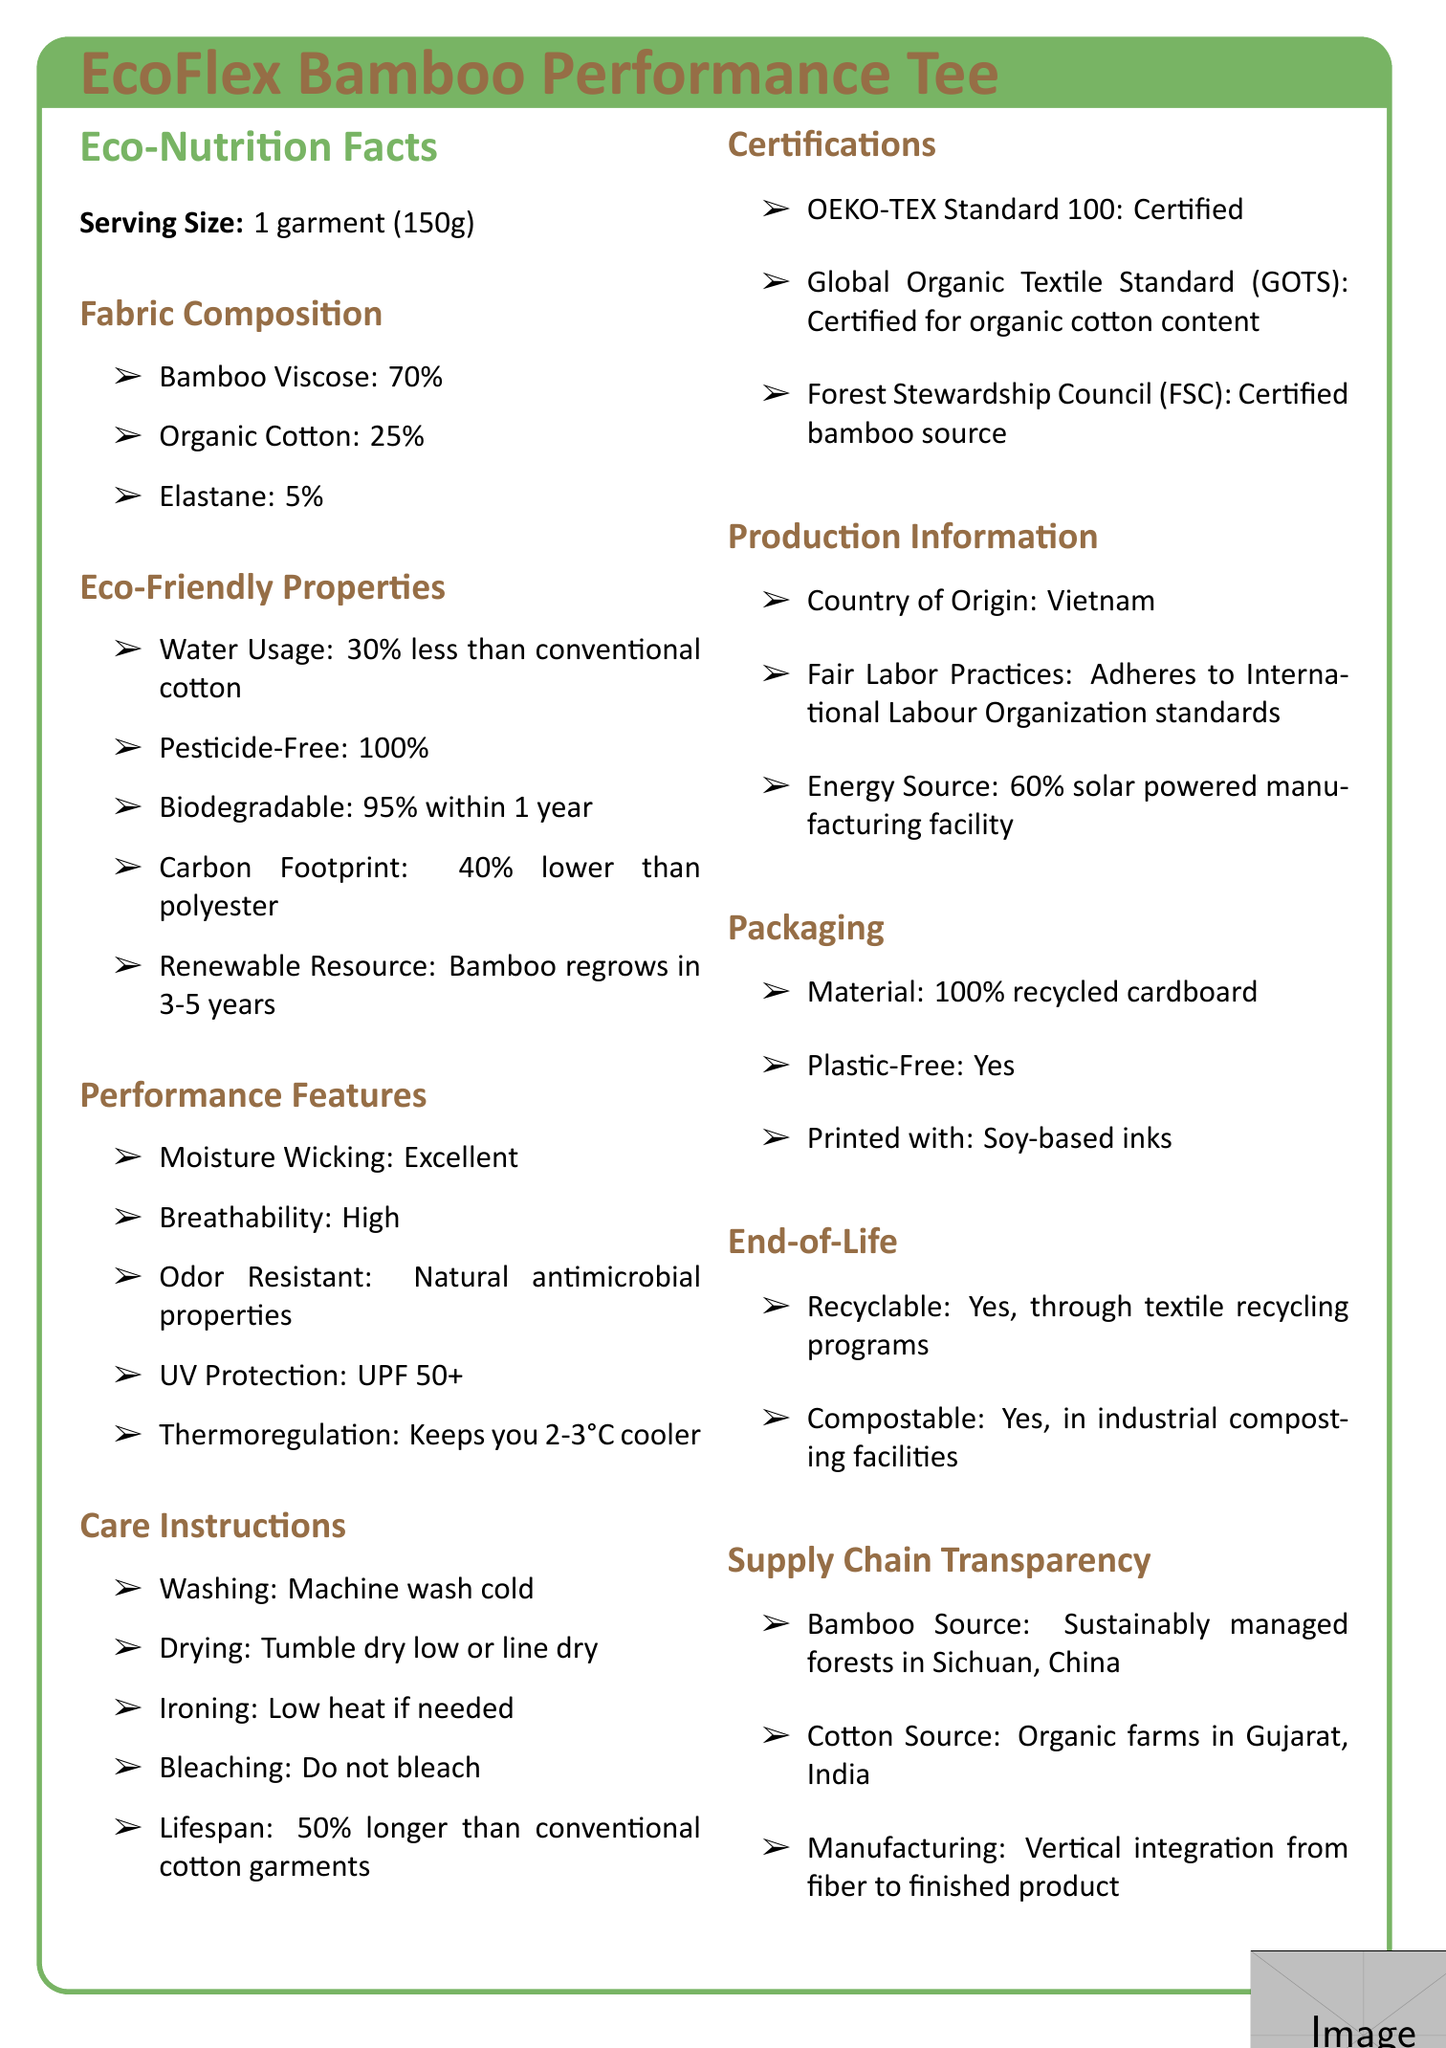what is the serving size of the EcoFlex Bamboo Performance Tee? The serving size is indicated at the beginning of the document under the "Eco-Nutrition Facts" section.
Answer: 1 garment (150g) What percentage of the EcoFlex Bamboo Performance Tee is made of organic cotton? The fabric composition states that the organic cotton content is 25%.
Answer: 25% How much water does the production of this garment save compared to conventional cotton garments? The eco-friendly properties section mentions that water usage is 30% less than conventional cotton.
Answer: 30% less What is one feature of the EcoFlex Bamboo Performance Tee that makes it particularly suitable for outdoor activities? The performance features list includes UV Protection with a UPF of 50+.
Answer: UV Protection: UPF 50+ What is the main energy source for manufacturing the EcoFlex Bamboo Performance Tee? This information is under the production information section.
Answer: 60% solar powered manufacturing facility Which certification ensures the organic cotton content in the EcoFlex Bamboo Performance Tee? A. OEKO-TEX Standard 100 B. Global Organic Textile Standard (GOTS) C. Forest Stewardship Council (FSC) The certifications section specifies that the Global Organic Textile Standard (GOTS) certifies the organic cotton content.
Answer: B. Global Organic Textile Standard (GOTS) Which of the following features is NOT listed under Performance Features? A. Moisture Wicking B. Wind Resistance C. Thermoregulation D. Odor Resistant The document lists Moisture Wicking, Thermoregulation, and Odor Resistant under Performance Features, but not Wind Resistance.
Answer: B. Wind Resistance Is the packaging of the EcoFlex Bamboo Performance Tee plastic-free? The packaging section states that the packaging is plastic-free.
Answer: Yes Summarize the main idea of this document. The EcoFlex Bamboo Performance Tee is highlighted for its sustainable production, excellent performance features, and eco-friendly packaging and certifications.
Answer: The EcoFlex Bamboo Performance Tee is a sustainable and high-performance activewear garment made from eco-friendly materials like bamboo viscose and organic cotton. It has beneficial properties such as reduced water usage, being pesticide-free, biodegradable, and having a lower carbon footprint. It offers excellent performance features like moisture-wicking, high breathability, odor resistance, UV protection, and thermoregulation. It is manufactured with fair labor practices in a solar-powered facility and comes in eco-friendly packaging. What is the exact percentage by which the carbon footprint of the EcoFlex Bamboo Performance Tee is lower than polyester? The eco-friendly properties section indicates that the carbon footprint is 40% lower than polyester.
Answer: 40% Which country is the source of bamboo used in the EcoFlex Bamboo Performance Tee? The supply chain transparency section mentions that the bamboo is sourced from sustainably managed forests in Sichuan, China.
Answer: Sichuan, China What certifications does the EcoFlex Bamboo Performance Tee have? The certifications section lists these three certifications.
Answer: OEKO-TEX Standard 100, Global Organic Textile Standard (GOTS), Forest Stewardship Council (FSC) What differentiates the bamboo used in this garment from other sources? The supply chain transparency section notes that the bamboo comes from sustainably managed forests in Sichuan, China.
Answer: Sustainably managed forests What percentage of the garment is biodegradable within one year? The eco-friendly properties section states that the garment is 95% biodegradable within one year.
Answer: 95% Where are the organic cotton farms located? The supply chain transparency section states that the cotton is sourced from organic farms in Gujarat, India.
Answer: Gujarat, India What is the expected lifespan of the EcoFlex Bamboo Performance Tee compared to conventional cotton garments? The care instructions section mentions that the lifespan is 50% longer than conventional cotton garments.
Answer: 50% longer What is the percentage of elastane in the EcoFlex Bamboo Performance Tee? The fabric composition indicates that the elastane content is 5%.
Answer: 5% Which of the following features is listed for the EcoFlex Bamboo Performance Tee? A. Waterproof B. Odor Resistant C. Windproof D. Wrinkle-Free The performance features section lists odor resistance as a feature, specifically mentioning natural antimicrobial properties.
Answer: B. Odor Resistant Are there any artificial pesticides used in the production of the EcoFlex Bamboo Performance Tee? The eco-friendly properties section states that the production is 100% pesticide-free.
Answer: No Which section of the document cannot be fully answered by the provided visual information? While the country of origin for manufacturing is mentioned as Vietnam, the specific components (e.g., where the elastane is sourced) are not detailed, thus "Cannot be determined" is the correct response for such a question.
Answer: Country of Origin for Specific Components 